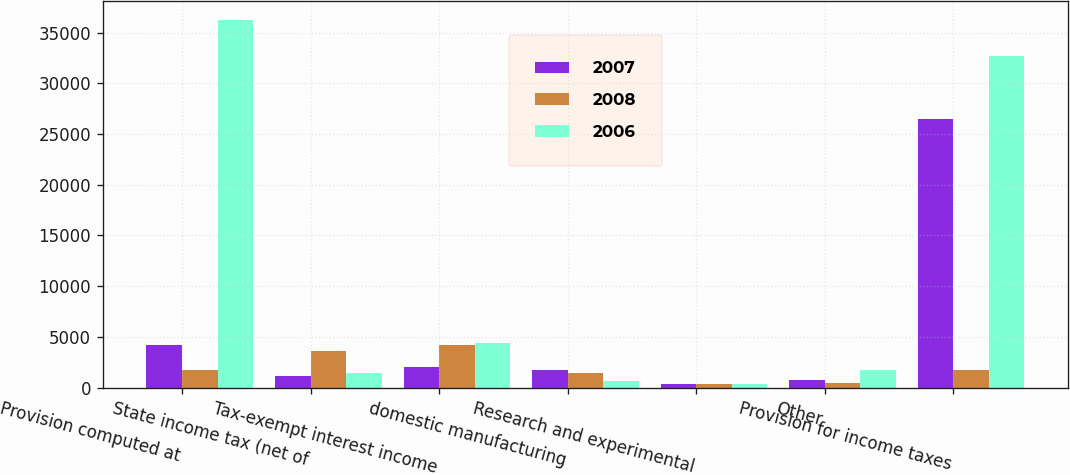Convert chart. <chart><loc_0><loc_0><loc_500><loc_500><stacked_bar_chart><ecel><fcel>Provision computed at<fcel>State income tax (net of<fcel>Tax-exempt interest income<fcel>domestic manufacturing<fcel>Research and experimental<fcel>Other<fcel>Provision for income taxes<nl><fcel>2007<fcel>4170<fcel>1127<fcel>1997<fcel>1715<fcel>400<fcel>753<fcel>26508<nl><fcel>2008<fcel>1715<fcel>3636<fcel>4173<fcel>1470<fcel>400<fcel>438<fcel>1715<nl><fcel>2006<fcel>36279<fcel>1412<fcel>4378<fcel>665<fcel>350<fcel>1776<fcel>32709<nl></chart> 